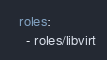Convert code to text. <code><loc_0><loc_0><loc_500><loc_500><_YAML_>  roles:
    - roles/libvirt</code> 